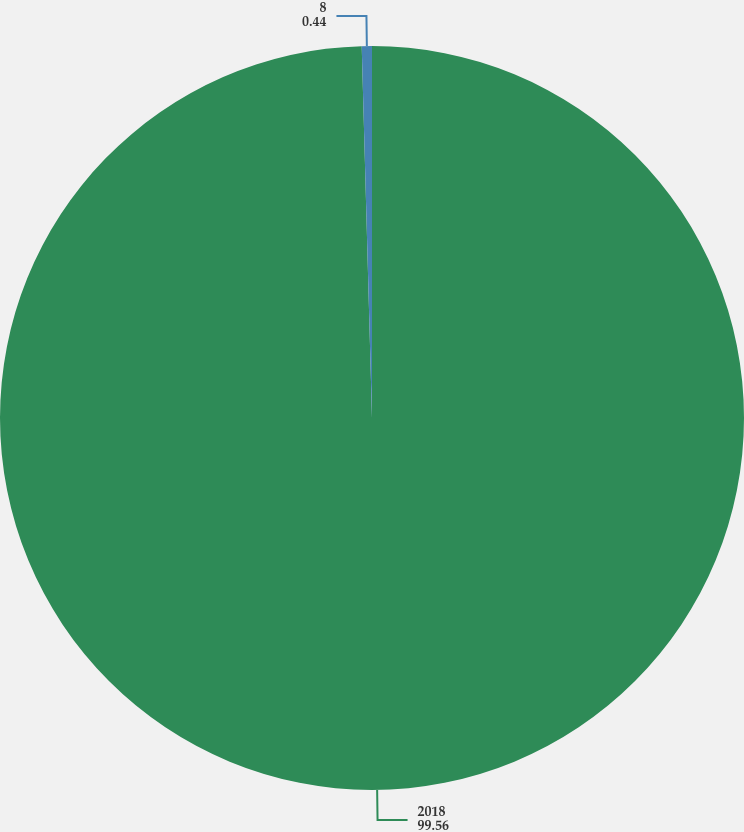Convert chart to OTSL. <chart><loc_0><loc_0><loc_500><loc_500><pie_chart><fcel>2018<fcel>8<nl><fcel>99.56%<fcel>0.44%<nl></chart> 